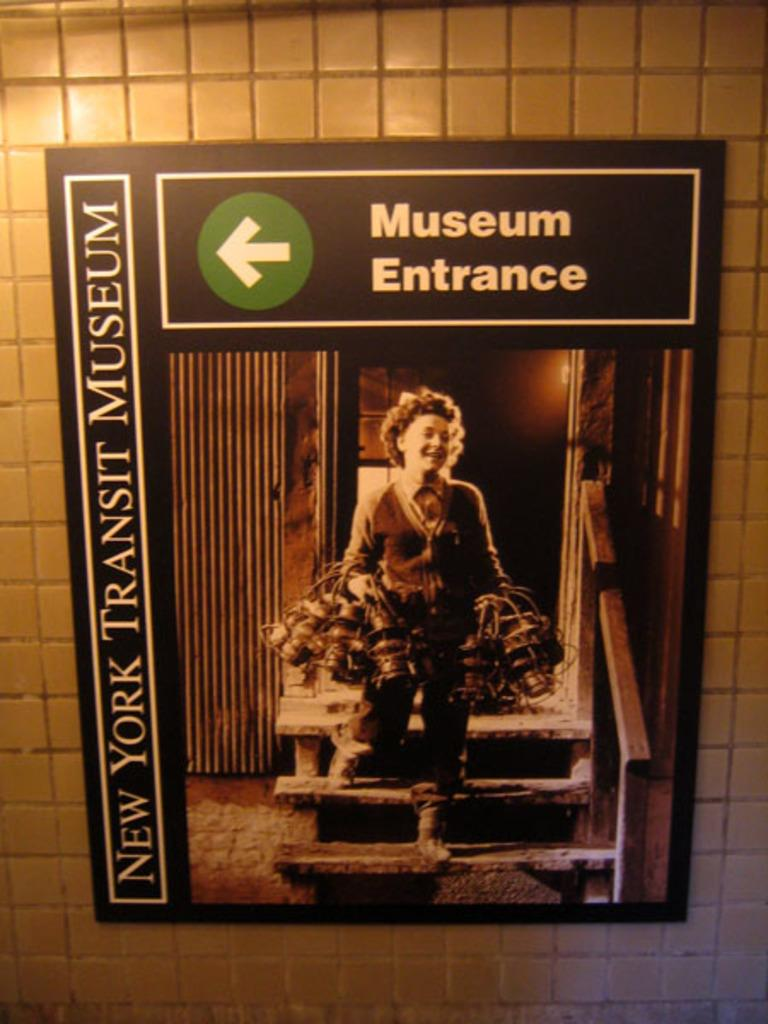<image>
Share a concise interpretation of the image provided. A sign for the museum entrance of the New York Transit Museum hangs on a wall. 